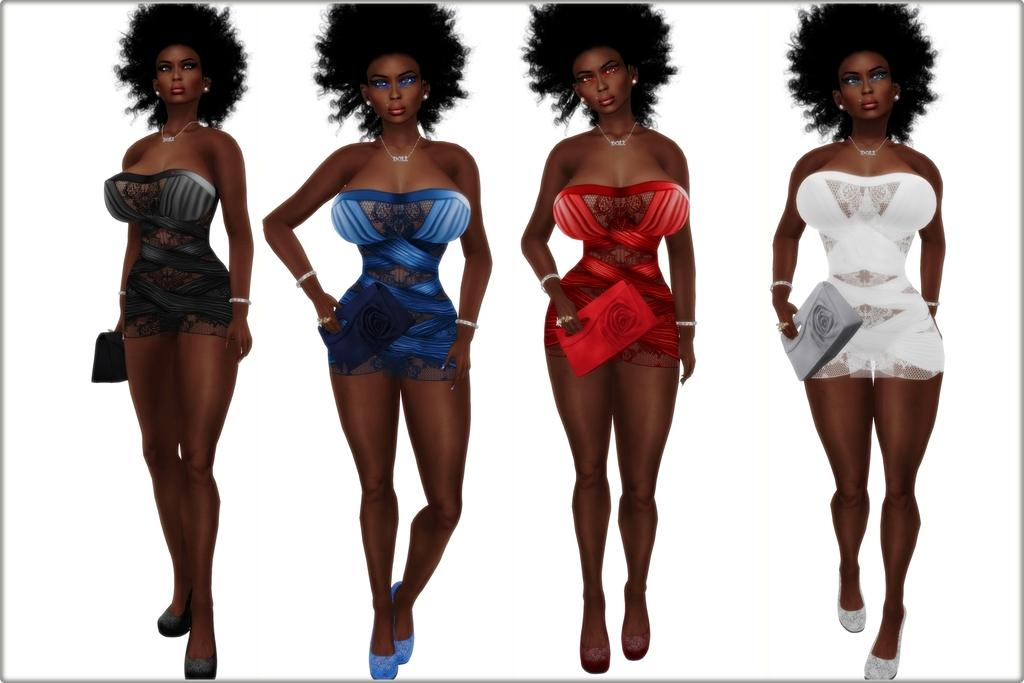What type of image is being described? The image is an animated picture. How many women are present in the image? There are four women in the image. What color is the background of the image? The background of the image is white. What type of care can be seen being provided to the loaf in the image? There is no loaf present in the image, and therefore no care can be provided to it. 